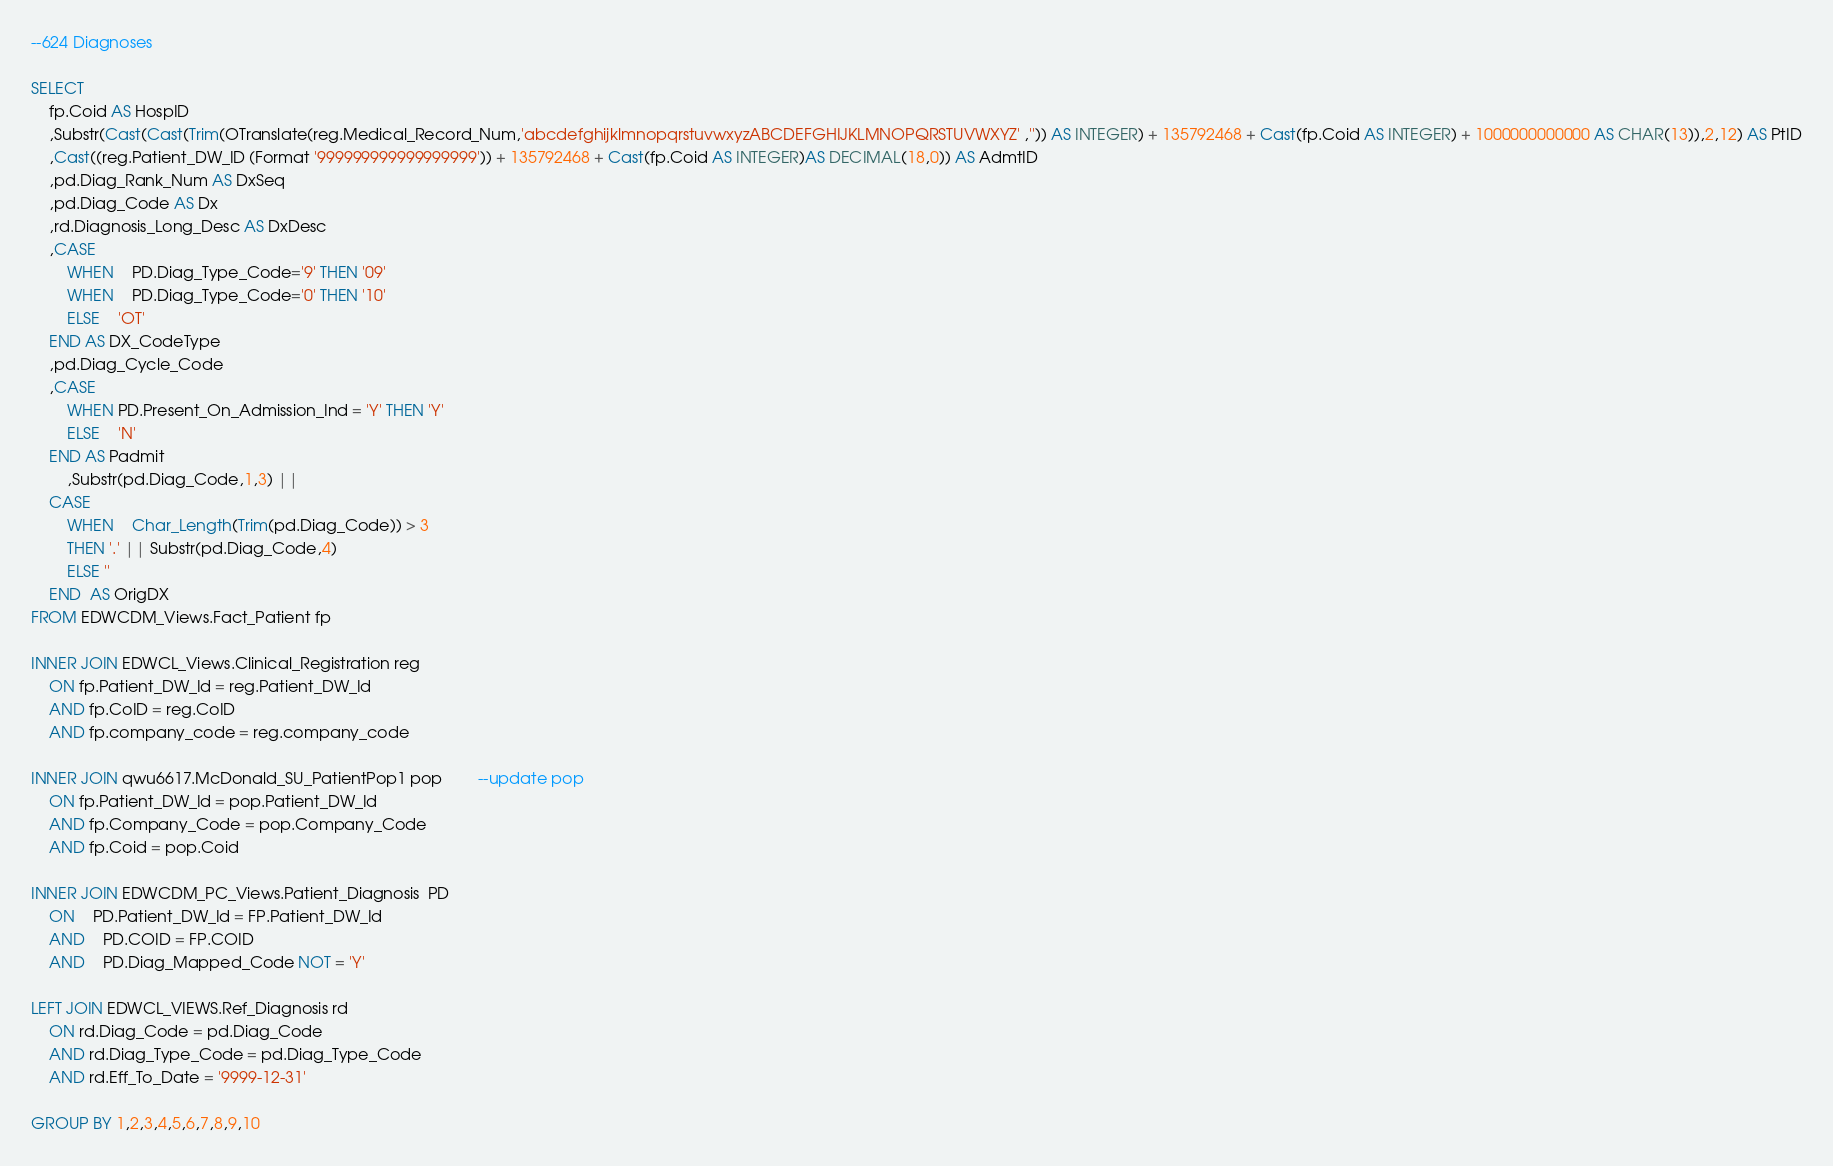<code> <loc_0><loc_0><loc_500><loc_500><_SQL_>--624 Diagnoses

SELECT
	fp.Coid AS HospID
	,Substr(Cast(Cast(Trim(OTranslate(reg.Medical_Record_Num,'abcdefghijklmnopqrstuvwxyzABCDEFGHIJKLMNOPQRSTUVWXYZ' ,'')) AS INTEGER) + 135792468 + Cast(fp.Coid AS INTEGER) + 1000000000000 AS CHAR(13)),2,12) AS PtID
	,Cast((reg.Patient_DW_ID (Format '999999999999999999')) + 135792468 + Cast(fp.Coid AS INTEGER)AS DECIMAL(18,0)) AS AdmtID
	,pd.Diag_Rank_Num AS DxSeq
	,pd.Diag_Code AS Dx
	,rd.Diagnosis_Long_Desc AS DxDesc
	,CASE	
		WHEN	PD.Diag_Type_Code='9' THEN '09' 
		WHEN    PD.Diag_Type_Code='0' THEN '10' 
		ELSE	'OT' 
	END AS DX_CodeType
	,pd.Diag_Cycle_Code
	,CASE	 
		WHEN PD.Present_On_Admission_Ind = 'Y' THEN 'Y' 
		ELSE	'N' 
	END AS Padmit
		,Substr(pd.Diag_Code,1,3) ||
	CASE 
		WHEN	Char_Length(Trim(pd.Diag_Code)) > 3
		THEN '.' || Substr(pd.Diag_Code,4)
		ELSE ''
	END  AS OrigDX
FROM EDWCDM_Views.Fact_Patient fp

INNER JOIN EDWCL_Views.Clinical_Registration reg
	ON fp.Patient_DW_Id = reg.Patient_DW_Id
	AND fp.CoID = reg.CoID
	AND fp.company_code = reg.company_code

INNER JOIN qwu6617.McDonald_SU_PatientPop1 pop		--update pop
	ON fp.Patient_DW_Id = pop.Patient_DW_Id
	AND fp.Company_Code = pop.Company_Code
	AND fp.Coid = pop.Coid

INNER JOIN EDWCDM_PC_Views.Patient_Diagnosis  PD
	ON	PD.Patient_DW_Id = FP.Patient_DW_Id  	   
	AND	PD.COID = FP.COID
	AND    PD.Diag_Mapped_Code NOT = 'Y'

LEFT JOIN EDWCL_VIEWS.Ref_Diagnosis rd
	ON rd.Diag_Code = pd.Diag_Code
	AND rd.Diag_Type_Code = pd.Diag_Type_Code
	AND rd.Eff_To_Date = '9999-12-31'

GROUP BY 1,2,3,4,5,6,7,8,9,10</code> 